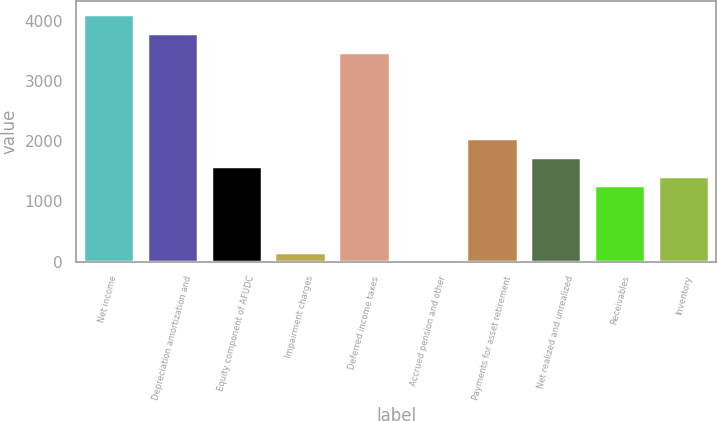Convert chart. <chart><loc_0><loc_0><loc_500><loc_500><bar_chart><fcel>Net income<fcel>Depreciation amortization and<fcel>Equity component of AFUDC<fcel>Impairment charges<fcel>Deferred income taxes<fcel>Accrued pension and other<fcel>Payments for asset retirement<fcel>Net realized and unrealized<fcel>Receivables<fcel>Inventory<nl><fcel>4112.6<fcel>3796.4<fcel>1583<fcel>160.1<fcel>3480.2<fcel>2<fcel>2057.3<fcel>1741.1<fcel>1266.8<fcel>1424.9<nl></chart> 